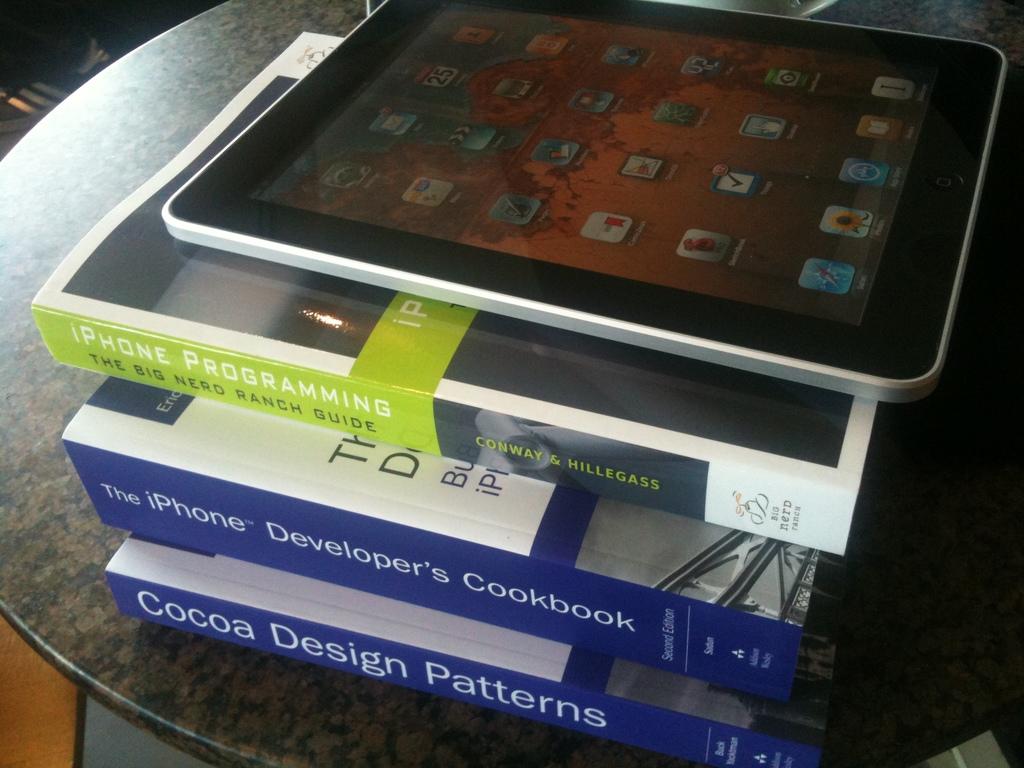What book is on the bottom of the stack?
Provide a succinct answer. Cocoa design patterns. What phone is the middle book about?
Your answer should be very brief. Iphone. 